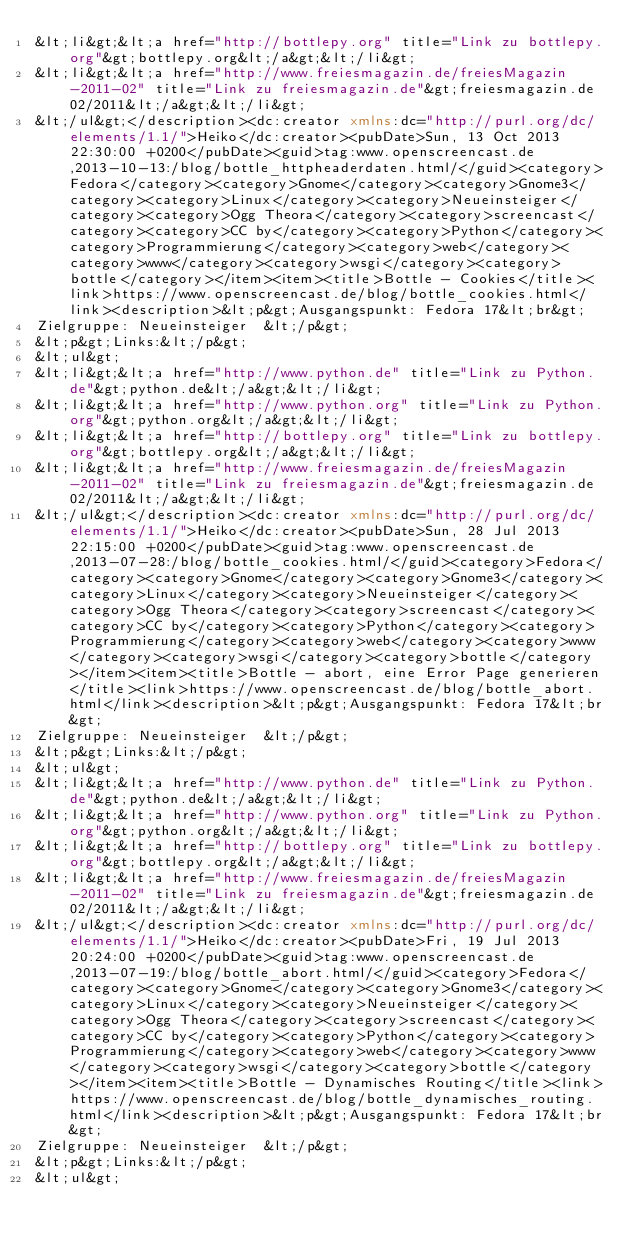Convert code to text. <code><loc_0><loc_0><loc_500><loc_500><_XML_>&lt;li&gt;&lt;a href="http://bottlepy.org" title="Link zu bottlepy.org"&gt;bottlepy.org&lt;/a&gt;&lt;/li&gt;
&lt;li&gt;&lt;a href="http://www.freiesmagazin.de/freiesMagazin-2011-02" title="Link zu freiesmagazin.de"&gt;freiesmagazin.de 02/2011&lt;/a&gt;&lt;/li&gt;
&lt;/ul&gt;</description><dc:creator xmlns:dc="http://purl.org/dc/elements/1.1/">Heiko</dc:creator><pubDate>Sun, 13 Oct 2013 22:30:00 +0200</pubDate><guid>tag:www.openscreencast.de,2013-10-13:/blog/bottle_httpheaderdaten.html/</guid><category>Fedora</category><category>Gnome</category><category>Gnome3</category><category>Linux</category><category>Neueinsteiger</category><category>Ogg Theora</category><category>screencast</category><category>CC by</category><category>Python</category><category>Programmierung</category><category>web</category><category>www</category><category>wsgi</category><category>bottle</category></item><item><title>Bottle - Cookies</title><link>https://www.openscreencast.de/blog/bottle_cookies.html</link><description>&lt;p&gt;Ausgangspunkt: Fedora 17&lt;br&gt;
Zielgruppe: Neueinsteiger  &lt;/p&gt;
&lt;p&gt;Links:&lt;/p&gt;
&lt;ul&gt;
&lt;li&gt;&lt;a href="http://www.python.de" title="Link zu Python.de"&gt;python.de&lt;/a&gt;&lt;/li&gt;
&lt;li&gt;&lt;a href="http://www.python.org" title="Link zu Python.org"&gt;python.org&lt;/a&gt;&lt;/li&gt;
&lt;li&gt;&lt;a href="http://bottlepy.org" title="Link zu bottlepy.org"&gt;bottlepy.org&lt;/a&gt;&lt;/li&gt;
&lt;li&gt;&lt;a href="http://www.freiesmagazin.de/freiesMagazin-2011-02" title="Link zu freiesmagazin.de"&gt;freiesmagazin.de 02/2011&lt;/a&gt;&lt;/li&gt;
&lt;/ul&gt;</description><dc:creator xmlns:dc="http://purl.org/dc/elements/1.1/">Heiko</dc:creator><pubDate>Sun, 28 Jul 2013 22:15:00 +0200</pubDate><guid>tag:www.openscreencast.de,2013-07-28:/blog/bottle_cookies.html/</guid><category>Fedora</category><category>Gnome</category><category>Gnome3</category><category>Linux</category><category>Neueinsteiger</category><category>Ogg Theora</category><category>screencast</category><category>CC by</category><category>Python</category><category>Programmierung</category><category>web</category><category>www</category><category>wsgi</category><category>bottle</category></item><item><title>Bottle - abort, eine Error Page generieren</title><link>https://www.openscreencast.de/blog/bottle_abort.html</link><description>&lt;p&gt;Ausgangspunkt: Fedora 17&lt;br&gt;
Zielgruppe: Neueinsteiger  &lt;/p&gt;
&lt;p&gt;Links:&lt;/p&gt;
&lt;ul&gt;
&lt;li&gt;&lt;a href="http://www.python.de" title="Link zu Python.de"&gt;python.de&lt;/a&gt;&lt;/li&gt;
&lt;li&gt;&lt;a href="http://www.python.org" title="Link zu Python.org"&gt;python.org&lt;/a&gt;&lt;/li&gt;
&lt;li&gt;&lt;a href="http://bottlepy.org" title="Link zu bottlepy.org"&gt;bottlepy.org&lt;/a&gt;&lt;/li&gt;
&lt;li&gt;&lt;a href="http://www.freiesmagazin.de/freiesMagazin-2011-02" title="Link zu freiesmagazin.de"&gt;freiesmagazin.de 02/2011&lt;/a&gt;&lt;/li&gt;
&lt;/ul&gt;</description><dc:creator xmlns:dc="http://purl.org/dc/elements/1.1/">Heiko</dc:creator><pubDate>Fri, 19 Jul 2013 20:24:00 +0200</pubDate><guid>tag:www.openscreencast.de,2013-07-19:/blog/bottle_abort.html/</guid><category>Fedora</category><category>Gnome</category><category>Gnome3</category><category>Linux</category><category>Neueinsteiger</category><category>Ogg Theora</category><category>screencast</category><category>CC by</category><category>Python</category><category>Programmierung</category><category>web</category><category>www</category><category>wsgi</category><category>bottle</category></item><item><title>Bottle - Dynamisches Routing</title><link>https://www.openscreencast.de/blog/bottle_dynamisches_routing.html</link><description>&lt;p&gt;Ausgangspunkt: Fedora 17&lt;br&gt;
Zielgruppe: Neueinsteiger  &lt;/p&gt;
&lt;p&gt;Links:&lt;/p&gt;
&lt;ul&gt;</code> 